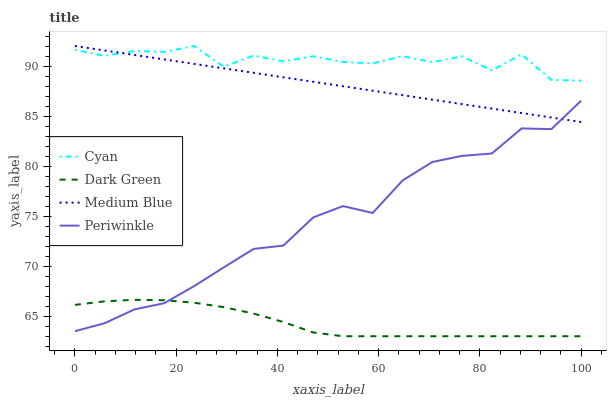Does Dark Green have the minimum area under the curve?
Answer yes or no. Yes. Does Cyan have the maximum area under the curve?
Answer yes or no. Yes. Does Periwinkle have the minimum area under the curve?
Answer yes or no. No. Does Periwinkle have the maximum area under the curve?
Answer yes or no. No. Is Medium Blue the smoothest?
Answer yes or no. Yes. Is Cyan the roughest?
Answer yes or no. Yes. Is Periwinkle the smoothest?
Answer yes or no. No. Is Periwinkle the roughest?
Answer yes or no. No. Does Periwinkle have the lowest value?
Answer yes or no. No. Does Medium Blue have the highest value?
Answer yes or no. Yes. Does Periwinkle have the highest value?
Answer yes or no. No. Is Dark Green less than Cyan?
Answer yes or no. Yes. Is Cyan greater than Periwinkle?
Answer yes or no. Yes. Does Dark Green intersect Periwinkle?
Answer yes or no. Yes. Is Dark Green less than Periwinkle?
Answer yes or no. No. Is Dark Green greater than Periwinkle?
Answer yes or no. No. Does Dark Green intersect Cyan?
Answer yes or no. No. 